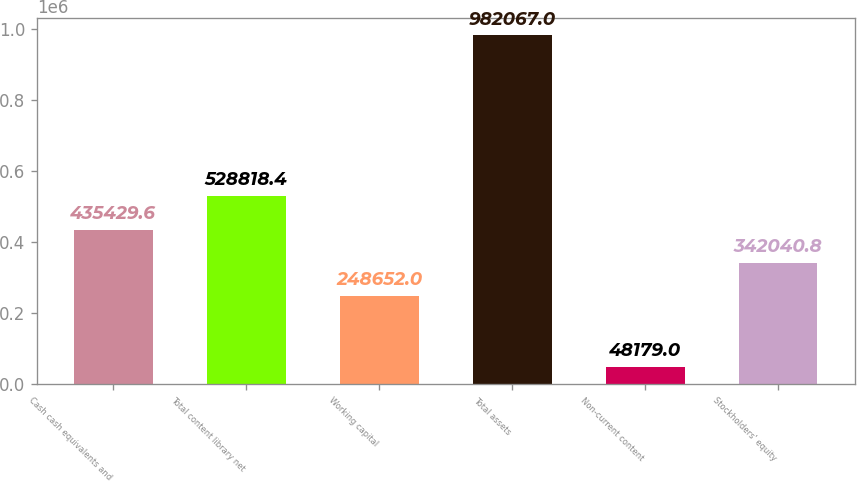Convert chart. <chart><loc_0><loc_0><loc_500><loc_500><bar_chart><fcel>Cash cash equivalents and<fcel>Total content library net<fcel>Working capital<fcel>Total assets<fcel>Non-current content<fcel>Stockholders' equity<nl><fcel>435430<fcel>528818<fcel>248652<fcel>982067<fcel>48179<fcel>342041<nl></chart> 